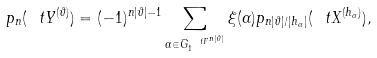<formula> <loc_0><loc_0><loc_500><loc_500>p _ { n } ( \ t Y ^ { ( \vartheta ) } ) = ( - 1 ) ^ { n | \vartheta | - 1 } \sum _ { \alpha \in \bar { G } _ { 1 } ^ { \ t F ^ { n | \vartheta | } } } \xi ( \alpha ) p _ { n | \vartheta | / | h _ { \alpha } | } ( \ t X ^ { ( h _ { \alpha } ) } ) ,</formula> 